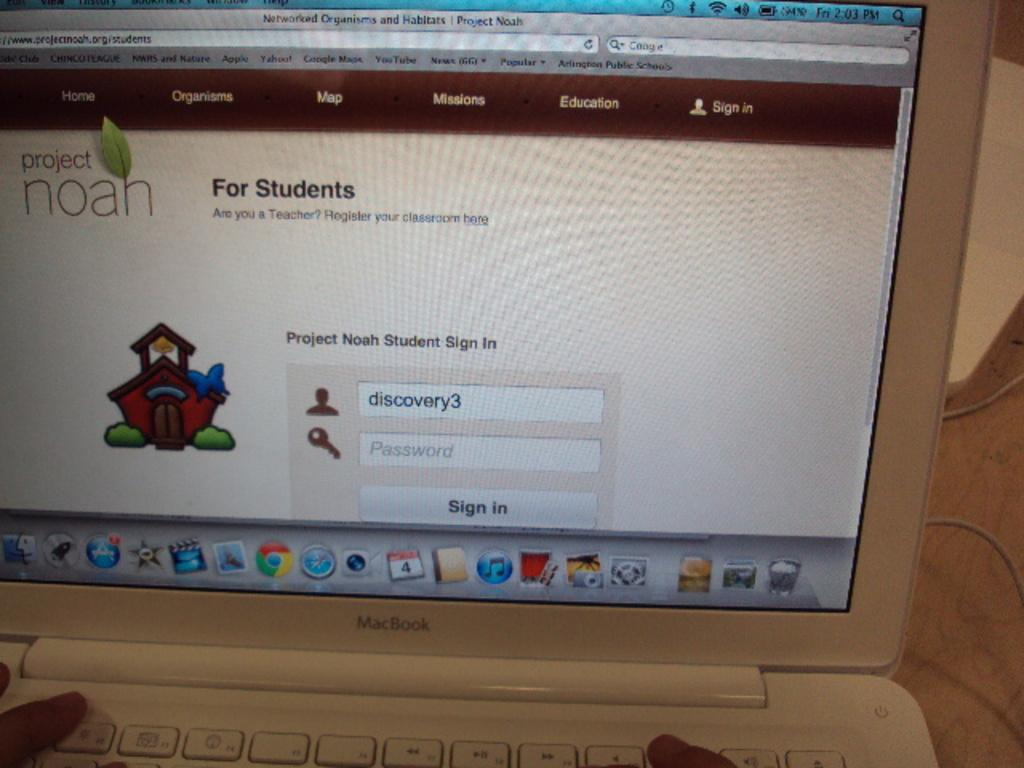<image>
Provide a brief description of the given image. A MacBook computer is being used to access Project Noan. 